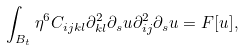<formula> <loc_0><loc_0><loc_500><loc_500>\int _ { B _ { t } } \eta ^ { 6 } C _ { i j k l } \partial _ { k l } ^ { 2 } \partial _ { s } u \partial _ { i j } ^ { 2 } \partial _ { s } u = F [ u ] ,</formula> 